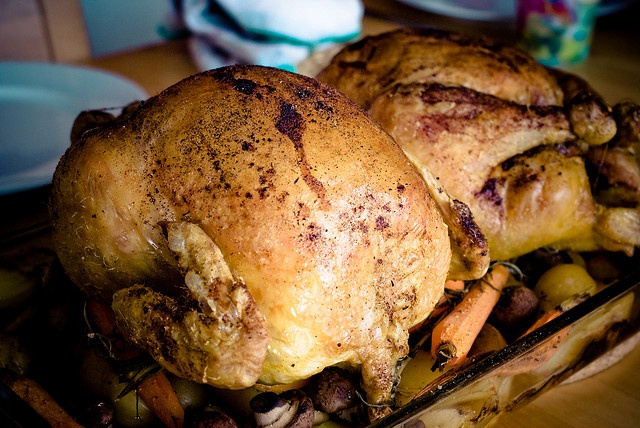Describe the objects in this image and their specific colors. I can see cup in black, teal, gray, and purple tones, carrot in black, orange, red, and maroon tones, carrot in black and maroon tones, carrot in black and maroon tones, and carrot in black, brown, maroon, and red tones in this image. 